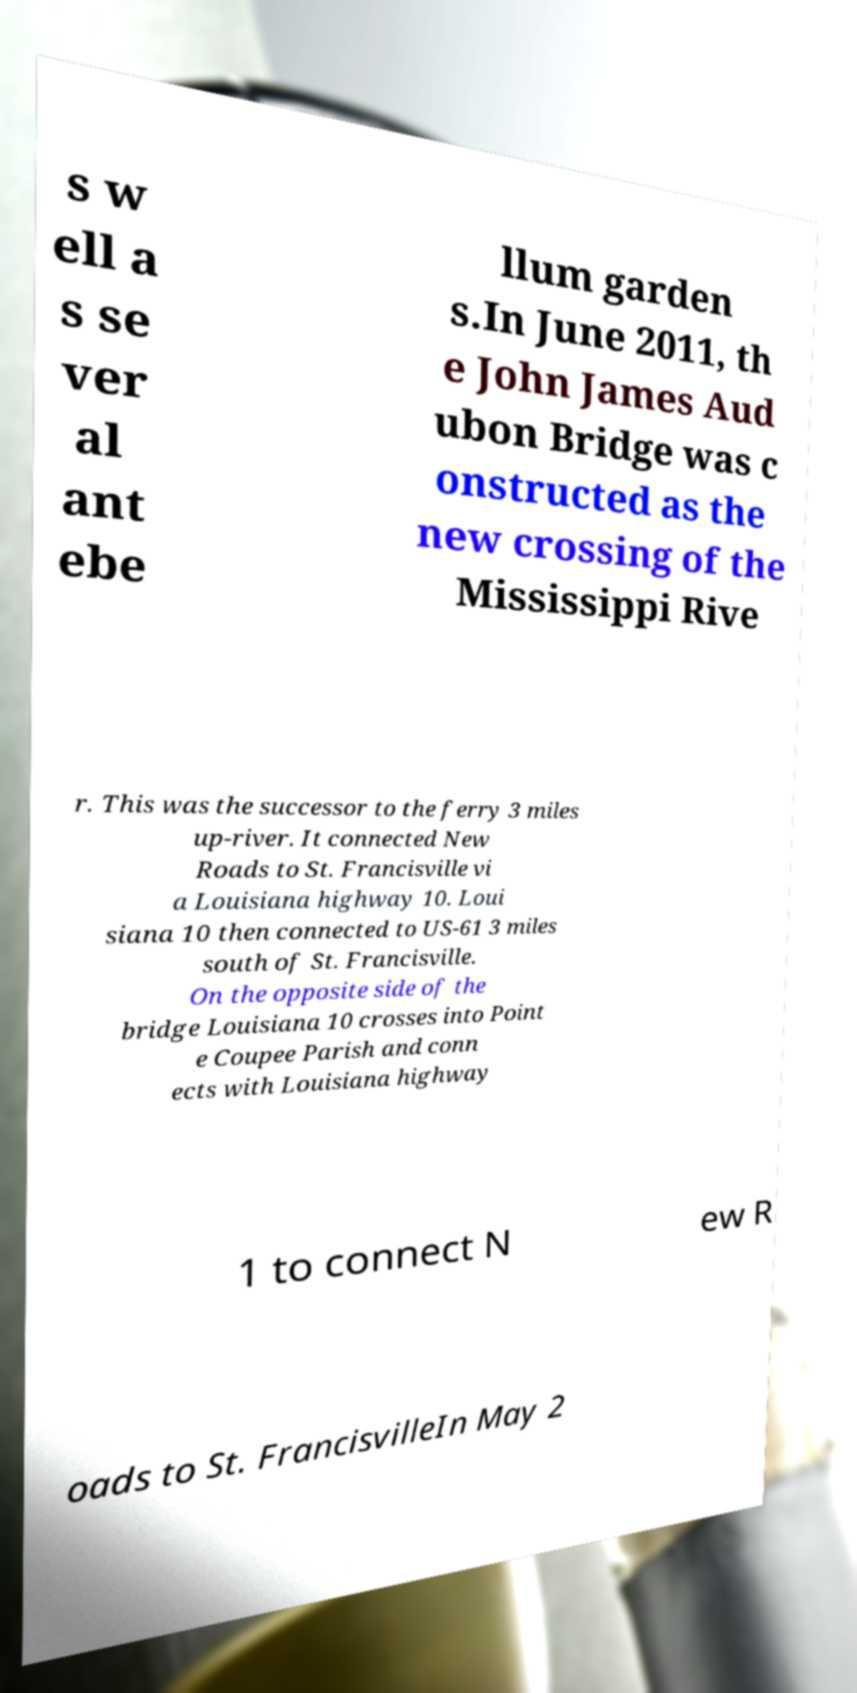Could you assist in decoding the text presented in this image and type it out clearly? s w ell a s se ver al ant ebe llum garden s.In June 2011, th e John James Aud ubon Bridge was c onstructed as the new crossing of the Mississippi Rive r. This was the successor to the ferry 3 miles up-river. It connected New Roads to St. Francisville vi a Louisiana highway 10. Loui siana 10 then connected to US-61 3 miles south of St. Francisville. On the opposite side of the bridge Louisiana 10 crosses into Point e Coupee Parish and conn ects with Louisiana highway 1 to connect N ew R oads to St. FrancisvilleIn May 2 